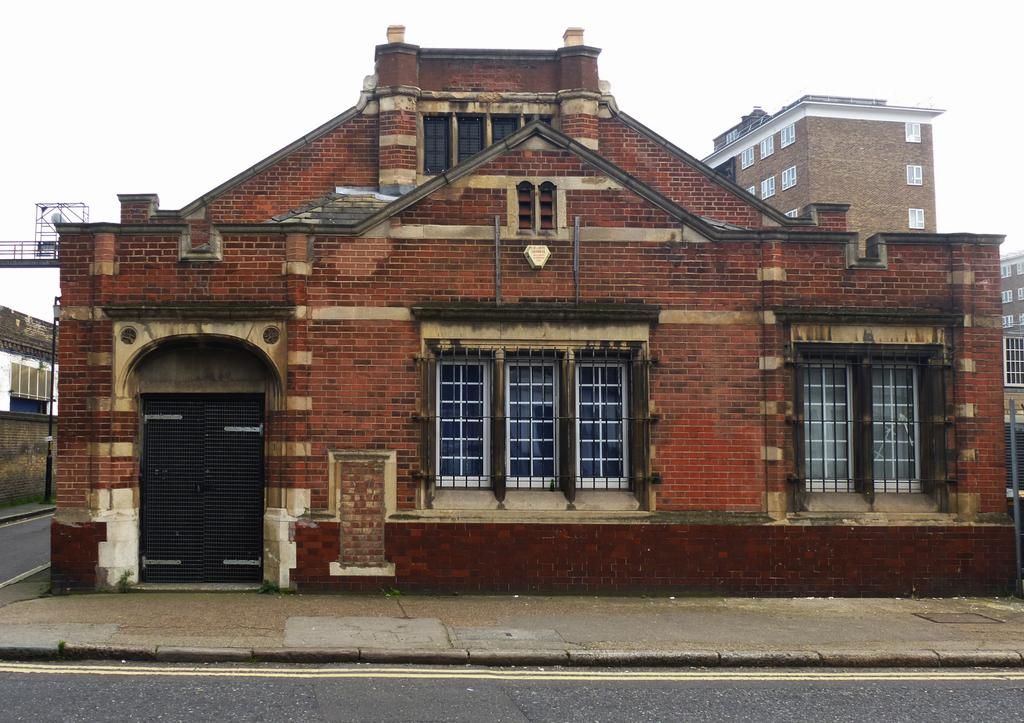What type of structures are visible in the image? There are buildings in the image. What features can be seen on the buildings? The buildings have windows. Is there any entrance visible in the image? Yes, there is a door in the image. What type of path is present in the image? There is a footpath in the image. What else can be seen on the ground in the image? There is a road in the image. What object is standing upright in the image? There is a pole in the image. What is the color of the sky in the image? The sky is white in the image. How many leaves are on the calendar in the image? There is no calendar or leaves present in the image. What type of respect is shown by the buildings in the image? The image does not depict any concept of respect; it simply shows buildings with windows, a door, a footpath, a road, and a pole. 